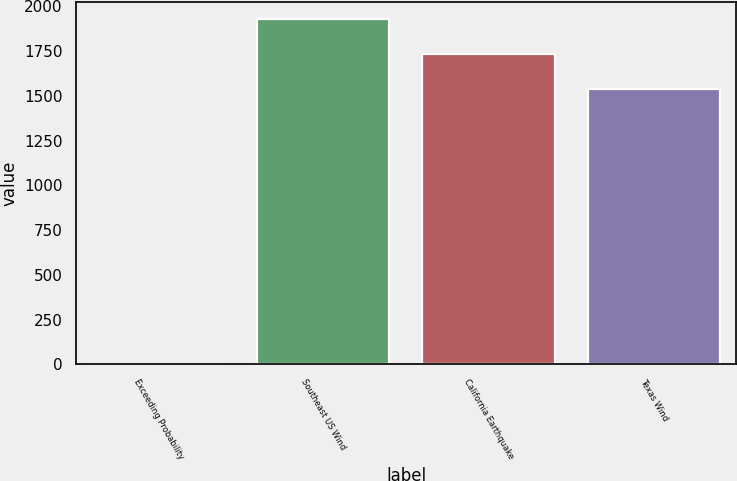<chart> <loc_0><loc_0><loc_500><loc_500><bar_chart><fcel>Exceeding Probability<fcel>Southeast US Wind<fcel>California Earthquake<fcel>Texas Wind<nl><fcel>0.4<fcel>1929<fcel>1731.86<fcel>1539<nl></chart> 